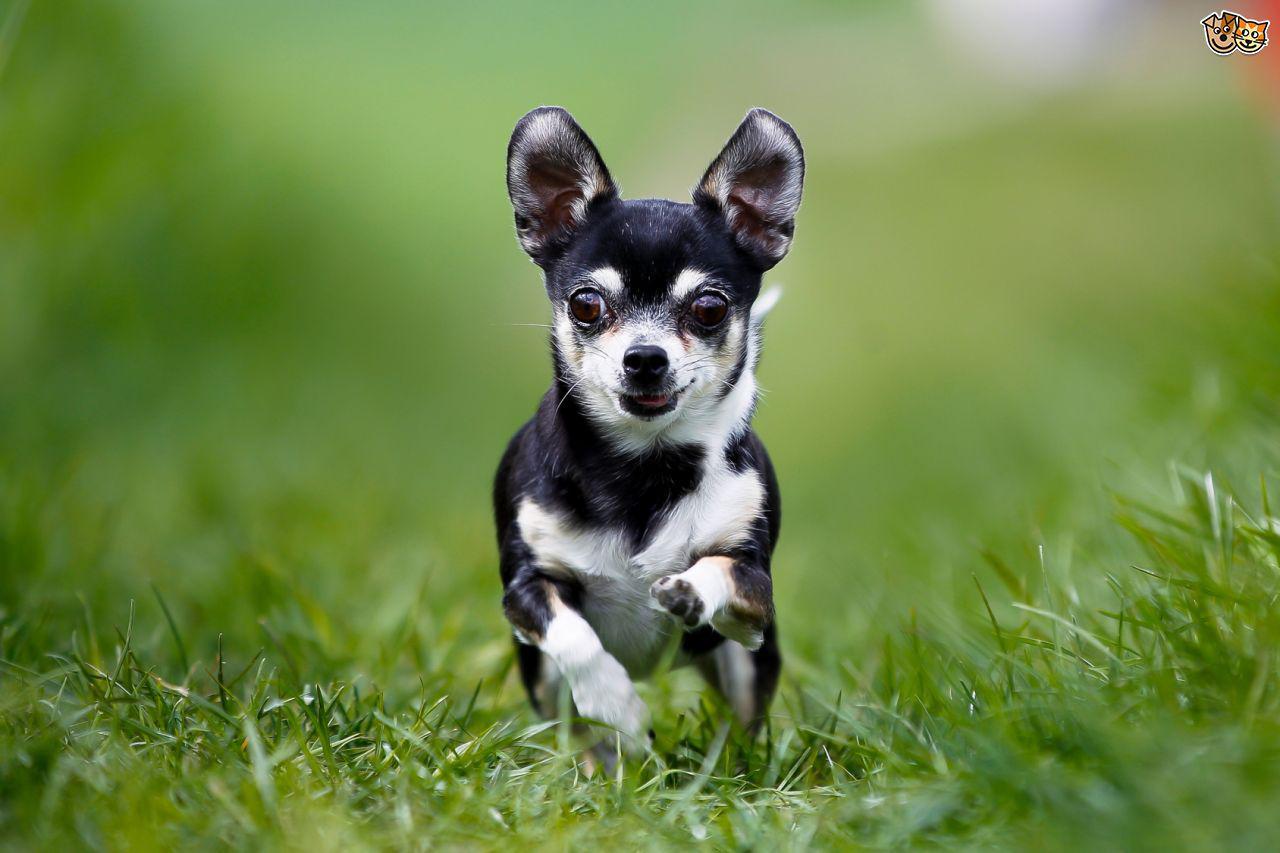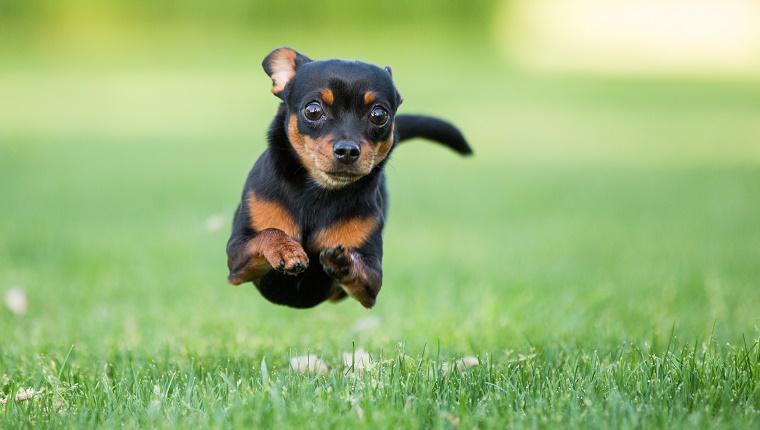The first image is the image on the left, the second image is the image on the right. Considering the images on both sides, is "A dog in one image is photographed while in mid-air." valid? Answer yes or no. Yes. 